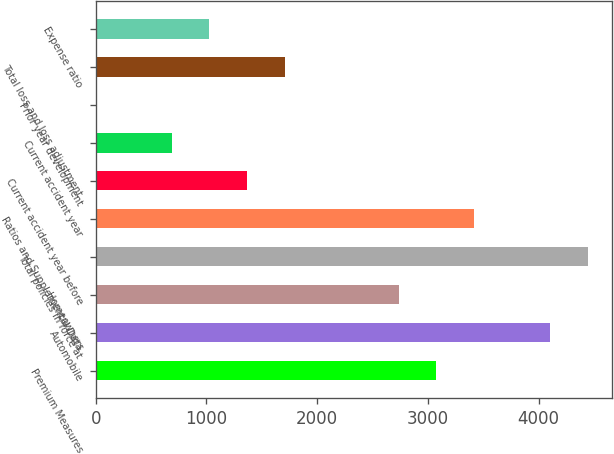<chart> <loc_0><loc_0><loc_500><loc_500><bar_chart><fcel>Premium Measures<fcel>Automobile<fcel>Homeowners<fcel>Total policies in force at<fcel>Ratios and Supplemental Data<fcel>Current accident year before<fcel>Current accident year<fcel>Prior year development<fcel>Total loss and loss adjustment<fcel>Expense ratio<nl><fcel>3077.3<fcel>4102.4<fcel>2735.6<fcel>4444.1<fcel>3419<fcel>1368.8<fcel>685.4<fcel>2<fcel>1710.5<fcel>1027.1<nl></chart> 